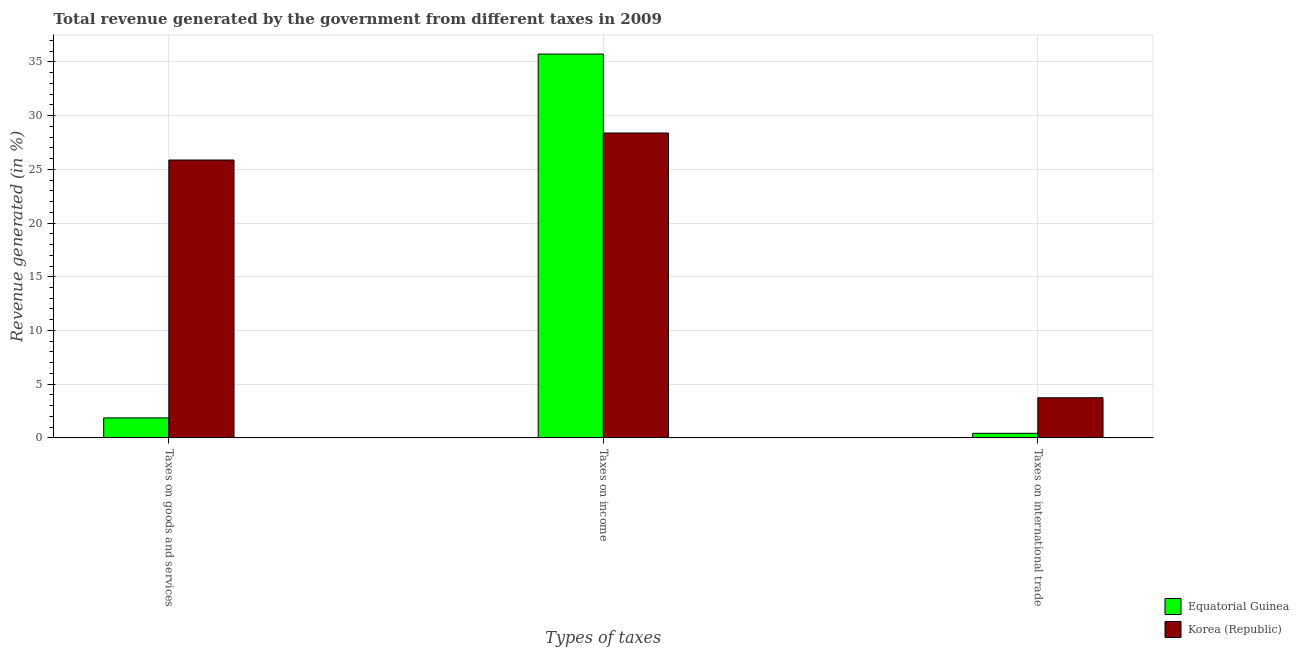Are the number of bars per tick equal to the number of legend labels?
Ensure brevity in your answer.  Yes. How many bars are there on the 1st tick from the left?
Provide a succinct answer. 2. How many bars are there on the 1st tick from the right?
Offer a very short reply. 2. What is the label of the 3rd group of bars from the left?
Your answer should be very brief. Taxes on international trade. What is the percentage of revenue generated by tax on international trade in Korea (Republic)?
Give a very brief answer. 3.74. Across all countries, what is the maximum percentage of revenue generated by tax on international trade?
Your answer should be compact. 3.74. Across all countries, what is the minimum percentage of revenue generated by tax on international trade?
Offer a very short reply. 0.42. In which country was the percentage of revenue generated by tax on international trade maximum?
Offer a very short reply. Korea (Republic). In which country was the percentage of revenue generated by taxes on goods and services minimum?
Your answer should be very brief. Equatorial Guinea. What is the total percentage of revenue generated by taxes on goods and services in the graph?
Keep it short and to the point. 27.72. What is the difference between the percentage of revenue generated by tax on international trade in Equatorial Guinea and that in Korea (Republic)?
Your response must be concise. -3.31. What is the difference between the percentage of revenue generated by tax on international trade in Equatorial Guinea and the percentage of revenue generated by taxes on goods and services in Korea (Republic)?
Make the answer very short. -25.44. What is the average percentage of revenue generated by taxes on income per country?
Offer a very short reply. 32.06. What is the difference between the percentage of revenue generated by taxes on goods and services and percentage of revenue generated by tax on international trade in Equatorial Guinea?
Make the answer very short. 1.43. In how many countries, is the percentage of revenue generated by taxes on goods and services greater than 4 %?
Offer a very short reply. 1. What is the ratio of the percentage of revenue generated by taxes on income in Equatorial Guinea to that in Korea (Republic)?
Ensure brevity in your answer.  1.26. Is the percentage of revenue generated by taxes on income in Korea (Republic) less than that in Equatorial Guinea?
Provide a short and direct response. Yes. Is the difference between the percentage of revenue generated by tax on international trade in Korea (Republic) and Equatorial Guinea greater than the difference between the percentage of revenue generated by taxes on income in Korea (Republic) and Equatorial Guinea?
Ensure brevity in your answer.  Yes. What is the difference between the highest and the second highest percentage of revenue generated by taxes on goods and services?
Give a very brief answer. 24.01. What is the difference between the highest and the lowest percentage of revenue generated by taxes on goods and services?
Make the answer very short. 24.01. Is the sum of the percentage of revenue generated by taxes on goods and services in Equatorial Guinea and Korea (Republic) greater than the maximum percentage of revenue generated by taxes on income across all countries?
Provide a succinct answer. No. What does the 1st bar from the left in Taxes on international trade represents?
Make the answer very short. Equatorial Guinea. What does the 1st bar from the right in Taxes on income represents?
Make the answer very short. Korea (Republic). Is it the case that in every country, the sum of the percentage of revenue generated by taxes on goods and services and percentage of revenue generated by taxes on income is greater than the percentage of revenue generated by tax on international trade?
Make the answer very short. Yes. How many bars are there?
Provide a short and direct response. 6. Does the graph contain any zero values?
Offer a terse response. No. Does the graph contain grids?
Offer a terse response. Yes. Where does the legend appear in the graph?
Offer a terse response. Bottom right. How are the legend labels stacked?
Make the answer very short. Vertical. What is the title of the graph?
Provide a succinct answer. Total revenue generated by the government from different taxes in 2009. What is the label or title of the X-axis?
Make the answer very short. Types of taxes. What is the label or title of the Y-axis?
Keep it short and to the point. Revenue generated (in %). What is the Revenue generated (in %) in Equatorial Guinea in Taxes on goods and services?
Ensure brevity in your answer.  1.86. What is the Revenue generated (in %) of Korea (Republic) in Taxes on goods and services?
Ensure brevity in your answer.  25.87. What is the Revenue generated (in %) in Equatorial Guinea in Taxes on income?
Give a very brief answer. 35.73. What is the Revenue generated (in %) in Korea (Republic) in Taxes on income?
Offer a very short reply. 28.38. What is the Revenue generated (in %) in Equatorial Guinea in Taxes on international trade?
Your response must be concise. 0.42. What is the Revenue generated (in %) in Korea (Republic) in Taxes on international trade?
Keep it short and to the point. 3.74. Across all Types of taxes, what is the maximum Revenue generated (in %) of Equatorial Guinea?
Provide a short and direct response. 35.73. Across all Types of taxes, what is the maximum Revenue generated (in %) of Korea (Republic)?
Keep it short and to the point. 28.38. Across all Types of taxes, what is the minimum Revenue generated (in %) of Equatorial Guinea?
Make the answer very short. 0.42. Across all Types of taxes, what is the minimum Revenue generated (in %) in Korea (Republic)?
Your answer should be compact. 3.74. What is the total Revenue generated (in %) in Equatorial Guinea in the graph?
Provide a succinct answer. 38.01. What is the total Revenue generated (in %) of Korea (Republic) in the graph?
Offer a terse response. 57.99. What is the difference between the Revenue generated (in %) in Equatorial Guinea in Taxes on goods and services and that in Taxes on income?
Your answer should be very brief. -33.87. What is the difference between the Revenue generated (in %) of Korea (Republic) in Taxes on goods and services and that in Taxes on income?
Keep it short and to the point. -2.52. What is the difference between the Revenue generated (in %) in Equatorial Guinea in Taxes on goods and services and that in Taxes on international trade?
Offer a terse response. 1.43. What is the difference between the Revenue generated (in %) in Korea (Republic) in Taxes on goods and services and that in Taxes on international trade?
Ensure brevity in your answer.  22.13. What is the difference between the Revenue generated (in %) of Equatorial Guinea in Taxes on income and that in Taxes on international trade?
Provide a succinct answer. 35.31. What is the difference between the Revenue generated (in %) in Korea (Republic) in Taxes on income and that in Taxes on international trade?
Your answer should be compact. 24.65. What is the difference between the Revenue generated (in %) in Equatorial Guinea in Taxes on goods and services and the Revenue generated (in %) in Korea (Republic) in Taxes on income?
Keep it short and to the point. -26.53. What is the difference between the Revenue generated (in %) in Equatorial Guinea in Taxes on goods and services and the Revenue generated (in %) in Korea (Republic) in Taxes on international trade?
Offer a terse response. -1.88. What is the difference between the Revenue generated (in %) in Equatorial Guinea in Taxes on income and the Revenue generated (in %) in Korea (Republic) in Taxes on international trade?
Keep it short and to the point. 32. What is the average Revenue generated (in %) of Equatorial Guinea per Types of taxes?
Keep it short and to the point. 12.67. What is the average Revenue generated (in %) in Korea (Republic) per Types of taxes?
Ensure brevity in your answer.  19.33. What is the difference between the Revenue generated (in %) of Equatorial Guinea and Revenue generated (in %) of Korea (Republic) in Taxes on goods and services?
Give a very brief answer. -24.01. What is the difference between the Revenue generated (in %) in Equatorial Guinea and Revenue generated (in %) in Korea (Republic) in Taxes on income?
Ensure brevity in your answer.  7.35. What is the difference between the Revenue generated (in %) in Equatorial Guinea and Revenue generated (in %) in Korea (Republic) in Taxes on international trade?
Your answer should be very brief. -3.31. What is the ratio of the Revenue generated (in %) in Equatorial Guinea in Taxes on goods and services to that in Taxes on income?
Keep it short and to the point. 0.05. What is the ratio of the Revenue generated (in %) of Korea (Republic) in Taxes on goods and services to that in Taxes on income?
Provide a short and direct response. 0.91. What is the ratio of the Revenue generated (in %) of Equatorial Guinea in Taxes on goods and services to that in Taxes on international trade?
Give a very brief answer. 4.37. What is the ratio of the Revenue generated (in %) of Korea (Republic) in Taxes on goods and services to that in Taxes on international trade?
Your response must be concise. 6.92. What is the ratio of the Revenue generated (in %) of Equatorial Guinea in Taxes on income to that in Taxes on international trade?
Keep it short and to the point. 84.09. What is the ratio of the Revenue generated (in %) of Korea (Republic) in Taxes on income to that in Taxes on international trade?
Make the answer very short. 7.6. What is the difference between the highest and the second highest Revenue generated (in %) in Equatorial Guinea?
Provide a short and direct response. 33.87. What is the difference between the highest and the second highest Revenue generated (in %) of Korea (Republic)?
Keep it short and to the point. 2.52. What is the difference between the highest and the lowest Revenue generated (in %) of Equatorial Guinea?
Ensure brevity in your answer.  35.31. What is the difference between the highest and the lowest Revenue generated (in %) of Korea (Republic)?
Your answer should be compact. 24.65. 